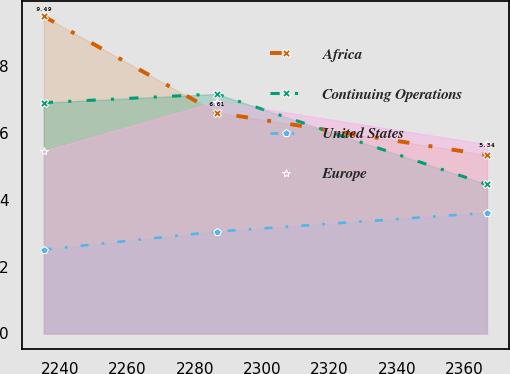Convert chart. <chart><loc_0><loc_0><loc_500><loc_500><line_chart><ecel><fcel>Africa<fcel>Continuing Operations<fcel>United States<fcel>Europe<nl><fcel>2235.25<fcel>9.49<fcel>6.91<fcel>2.51<fcel>5.46<nl><fcel>2286.51<fcel>6.61<fcel>7.17<fcel>3.05<fcel>6.94<nl><fcel>2366.62<fcel>5.34<fcel>4.46<fcel>3.61<fcel>5.66<nl></chart> 